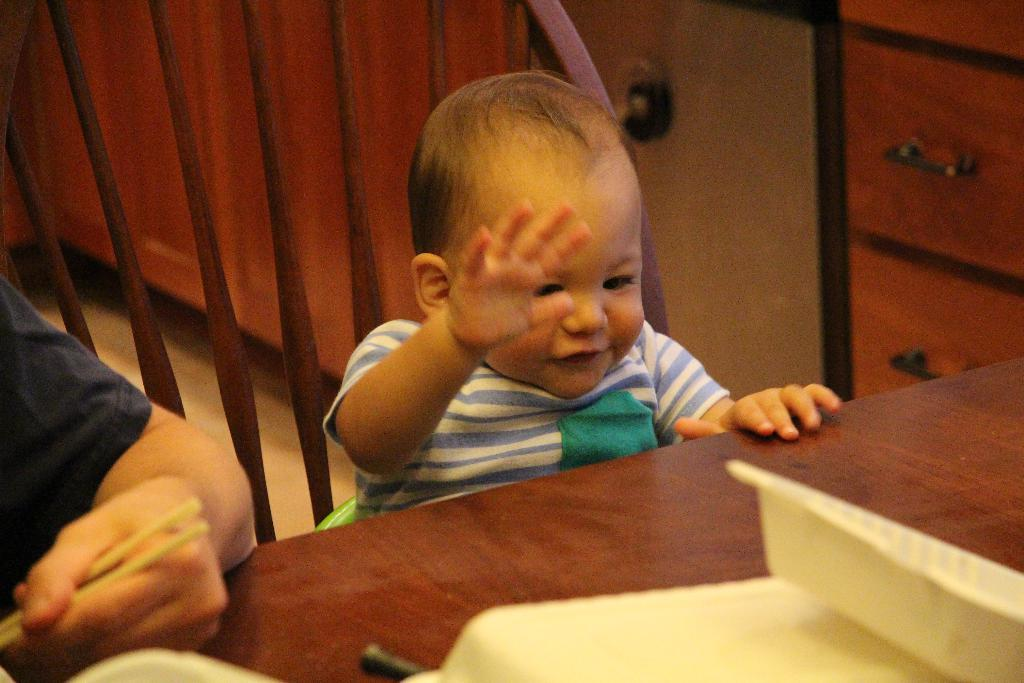What is the main subject of the image? There is a baby in the image. Who is near the baby? There is a person near the baby. What is the person holding? The person is holding chopsticks. What is in front of the person? There is a table in front of the person. What is the baby's tendency to achieve high scores in school? The image does not provide any information about the baby's academic performance or achievements. 